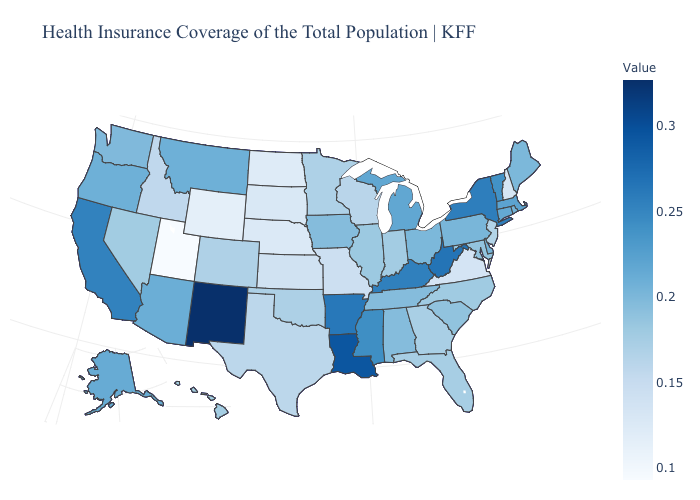Does Oregon have the highest value in the West?
Write a very short answer. No. 